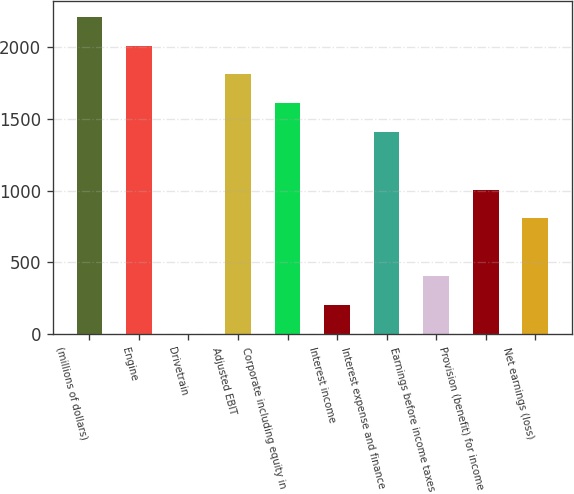Convert chart. <chart><loc_0><loc_0><loc_500><loc_500><bar_chart><fcel>(millions of dollars)<fcel>Engine<fcel>Drivetrain<fcel>Adjusted EBIT<fcel>Corporate including equity in<fcel>Interest income<fcel>Interest expense and finance<fcel>Earnings before income taxes<fcel>Provision (benefit) for income<fcel>Net earnings (loss)<nl><fcel>2208.31<fcel>2008<fcel>4.9<fcel>1807.69<fcel>1607.38<fcel>205.21<fcel>1407.07<fcel>405.52<fcel>1006.45<fcel>806.14<nl></chart> 